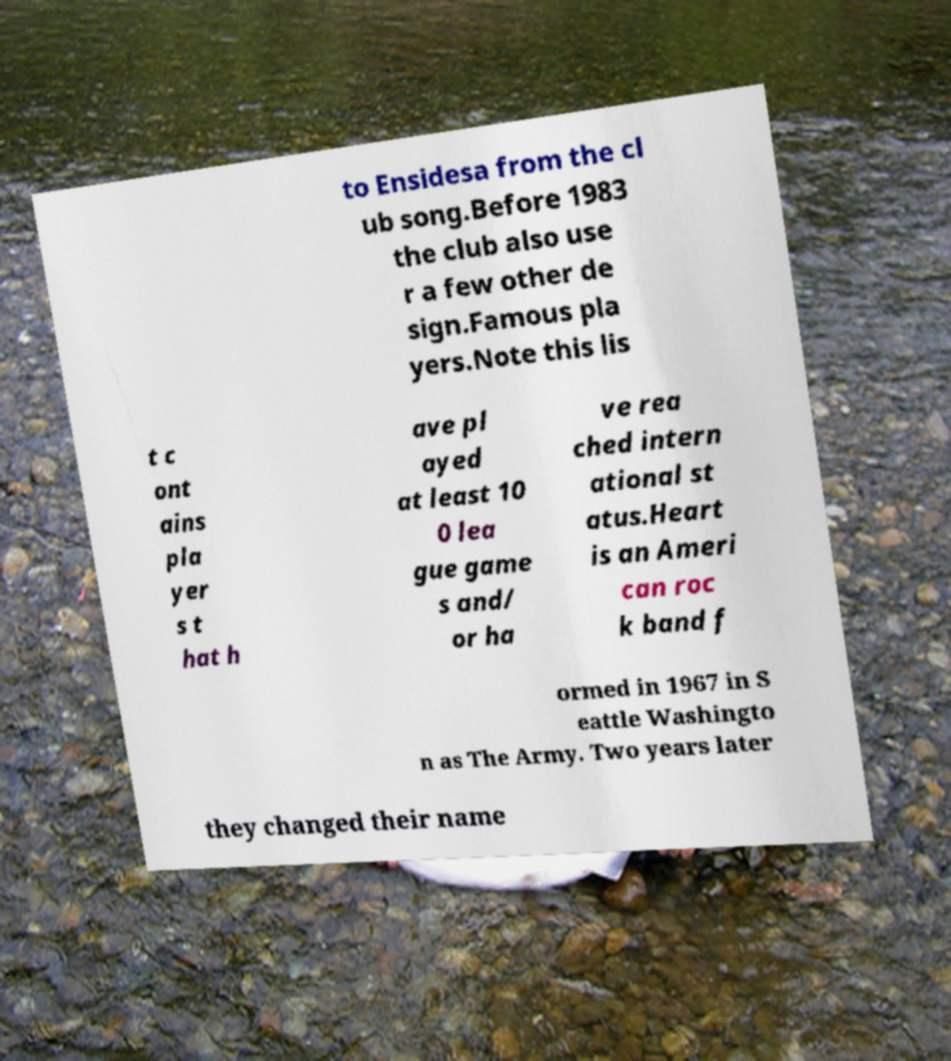Please read and relay the text visible in this image. What does it say? to Ensidesa from the cl ub song.Before 1983 the club also use r a few other de sign.Famous pla yers.Note this lis t c ont ains pla yer s t hat h ave pl ayed at least 10 0 lea gue game s and/ or ha ve rea ched intern ational st atus.Heart is an Ameri can roc k band f ormed in 1967 in S eattle Washingto n as The Army. Two years later they changed their name 